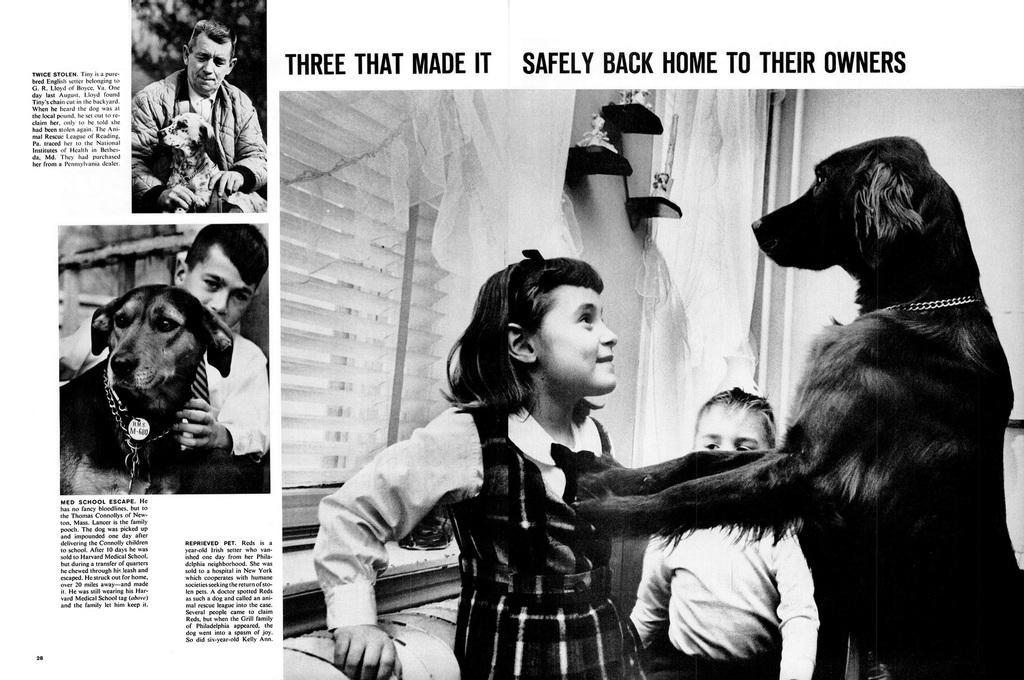Please provide a concise description of this image. In this picture we can see the newspaper. On the right there is a dog who is standing near to the girl. Beside her we can see the girl who is standing near to the window and window blind. On the left we can see a man who is holding a dog's neck. In the top left corner there is a man who is sitting near the dog. Beside him there is a tree. In the bottom left we can see the quotations. 